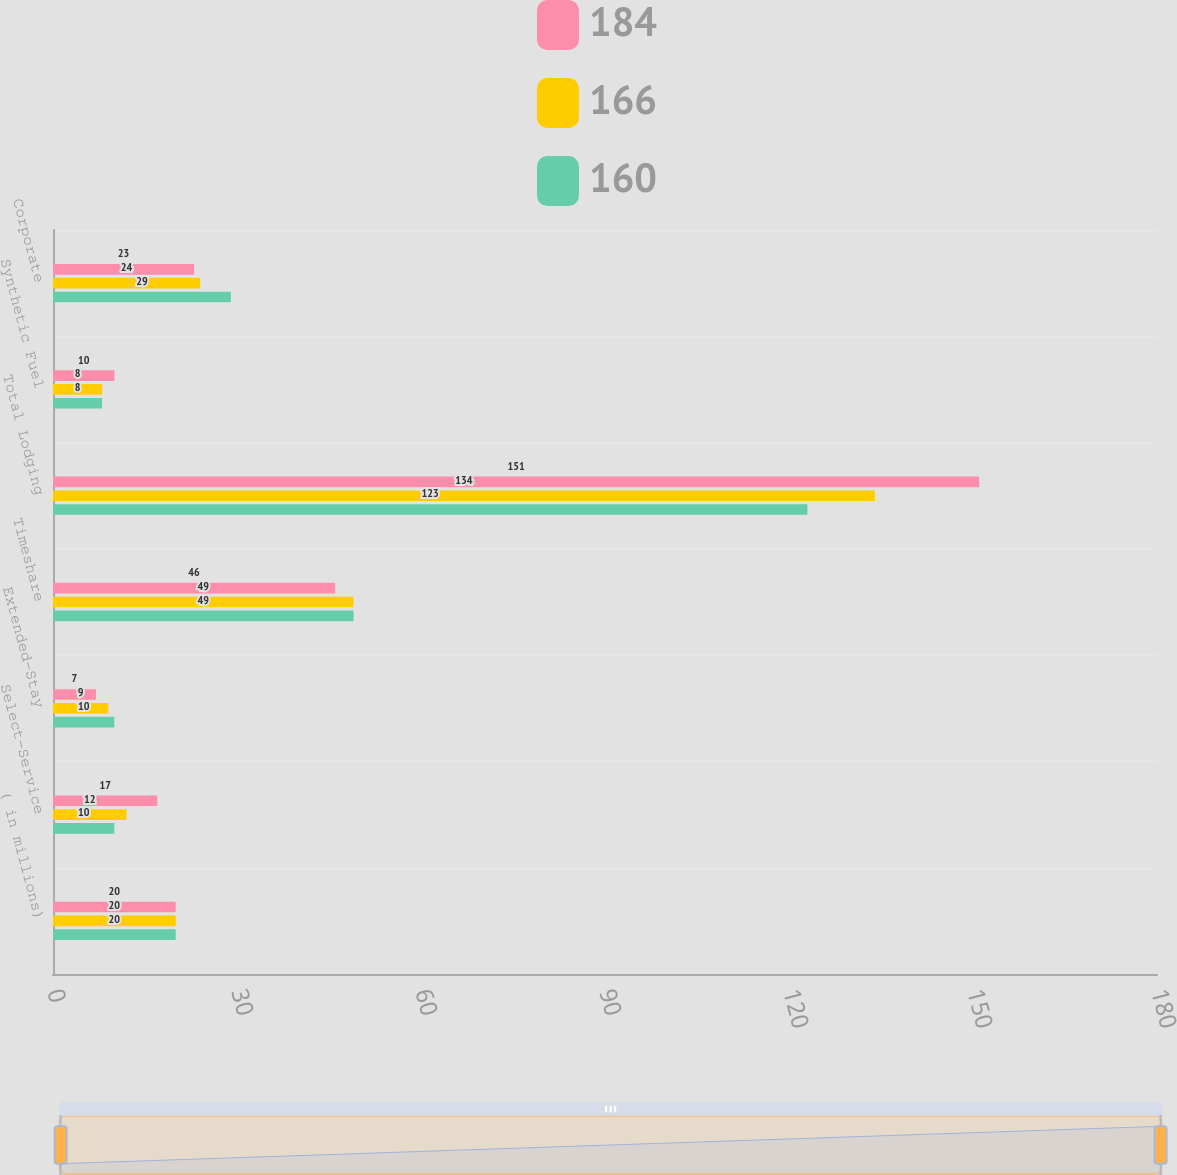Convert chart. <chart><loc_0><loc_0><loc_500><loc_500><stacked_bar_chart><ecel><fcel>( in millions)<fcel>Select-Service<fcel>Extended-Stay<fcel>Timeshare<fcel>Total Lodging<fcel>Synthetic Fuel<fcel>Corporate<nl><fcel>184<fcel>20<fcel>17<fcel>7<fcel>46<fcel>151<fcel>10<fcel>23<nl><fcel>166<fcel>20<fcel>12<fcel>9<fcel>49<fcel>134<fcel>8<fcel>24<nl><fcel>160<fcel>20<fcel>10<fcel>10<fcel>49<fcel>123<fcel>8<fcel>29<nl></chart> 